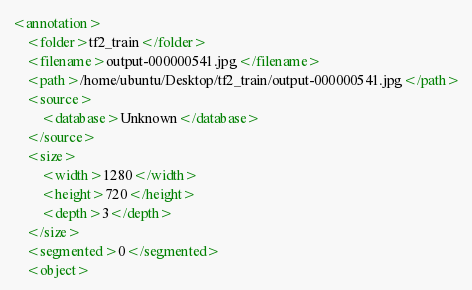Convert code to text. <code><loc_0><loc_0><loc_500><loc_500><_XML_><annotation>
    <folder>tf2_train</folder>
    <filename>output-000000541.jpg</filename>
    <path>/home/ubuntu/Desktop/tf2_train/output-000000541.jpg</path>
    <source>
        <database>Unknown</database>
    </source>
    <size>
        <width>1280</width>
        <height>720</height>
        <depth>3</depth>
    </size>
    <segmented>0</segmented>
    <object></code> 